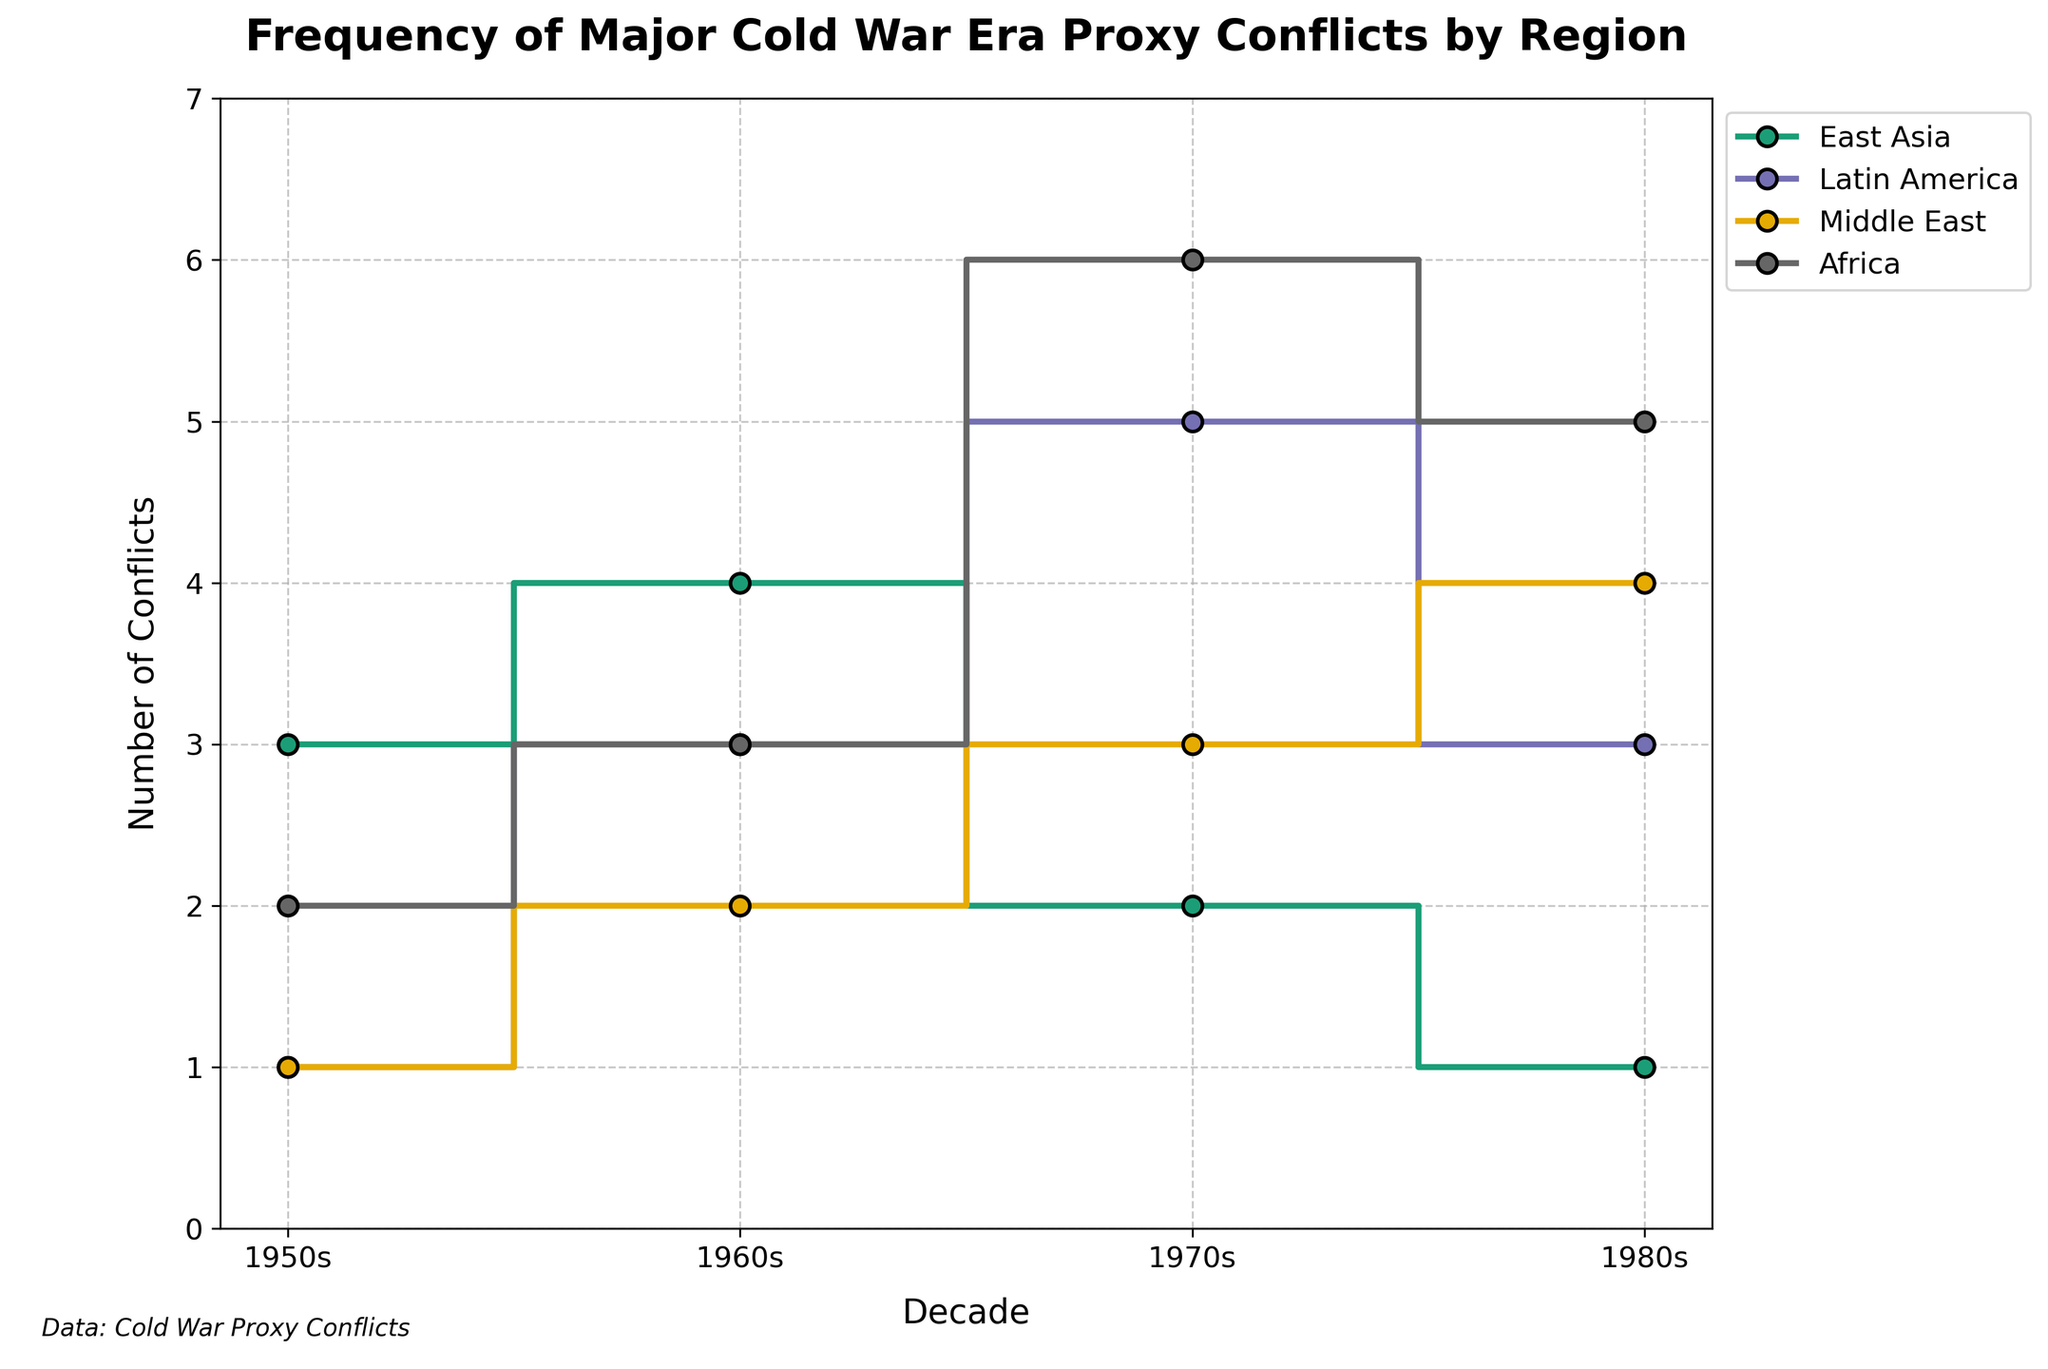What is the title of the figure? The title is usually positioned at the top of the plot, often in a larger font size or bold to stand out. In this case, it is written as 'Frequency of Major Cold War Era Proxy Conflicts by Region'.
Answer: Frequency of Major Cold War Era Proxy Conflicts by Region Which region had the highest number of conflicts in the 1970s? To determine this, identify the data points for the 1970s on the x-axis and compare the heights of the step plots for each region. East Asia had 2, Latin America had 5, Middle East had 3, and Africa had 6 conflicts. Africa is the highest.
Answer: Africa How did the number of conflicts in Latin America change from the 1950s to the 1960s? Look at the step plots for Latin America. In the 1950s, there was 1 conflict and by the 1960s, there were 3 conflicts. Subtract 1 from 3 to get a change of 2 conflicts.
Answer: Increased by 2 Which decade had the overall highest number of conflicts across all regions? Sum the number of conflicts for each decade across all regions. 1950s: 7, 1960s: 12, 1970s: 16, 1980s: 13. The 1970s had the highest number of conflicts.
Answer: 1970s How does the number of conflicts in East Asia in the 1980s compare to the number of conflicts in the Middle East in the same decade? Compare the step heights for East Asia and the Middle East in the 1980s. East Asia had 1 conflict, while the Middle East had 4 conflicts. The Middle East had more conflicts.
Answer: Middle East had 3 more conflicts What is the trend of conflicts in the Middle East from 1950s to 1980s? Examine the step plots for the Middle East across the decades. The conflicts increase from 1 in the 1950s to 2 in the 1960s, 3 in the 1970s, and 4 in the 1980s, showing a consistent upward trend.
Answer: Increasing By how much did the number of conflicts in Africa change from the 1950s to the 1980s? Look at the step plots for Africa. In the 1950s, there were 2 conflicts and in the 1980s, there were 5 conflicts. The change is 5 minus 2, which equals 3.
Answer: Increased by 3 Which region experienced the least number of conflicts in the 1950s? Observe the step heights for each region in the 1950s. Latin America and the Middle East both had 1 conflict, while East Asia had 3, and Africa had 2. Thus, Latin America and the Middle East had the least.
Answer: Latin America and Middle East What decade saw the highest number of conflicts in East Asia? Identify the maximum step height for East Asia across the decades. The highest value is 4 conflicts in the 1960s.
Answer: 1960s Which region shows a decreasing trend in the number of conflicts from the 1960s to the 1980s? Check each region's step plot from the 1960s to the 1980s for a downward trend. East Asia is the region that shows a decrease from 4 in the 1960s to 1 in the 1980s.
Answer: East Asia 